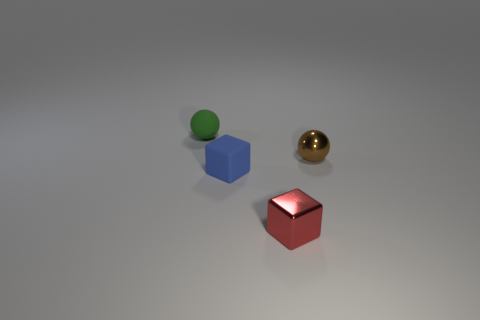Can you describe the size and shape of the objects in the image? The image shows three distinct objects. From left to right: a small green sphere, a medium-sized blue cube, and a small golden sphere. Each object showcases a clearly defined geometric shape, with the green and golden objects having a spherical shape, and the blue object being a perfect cube. 